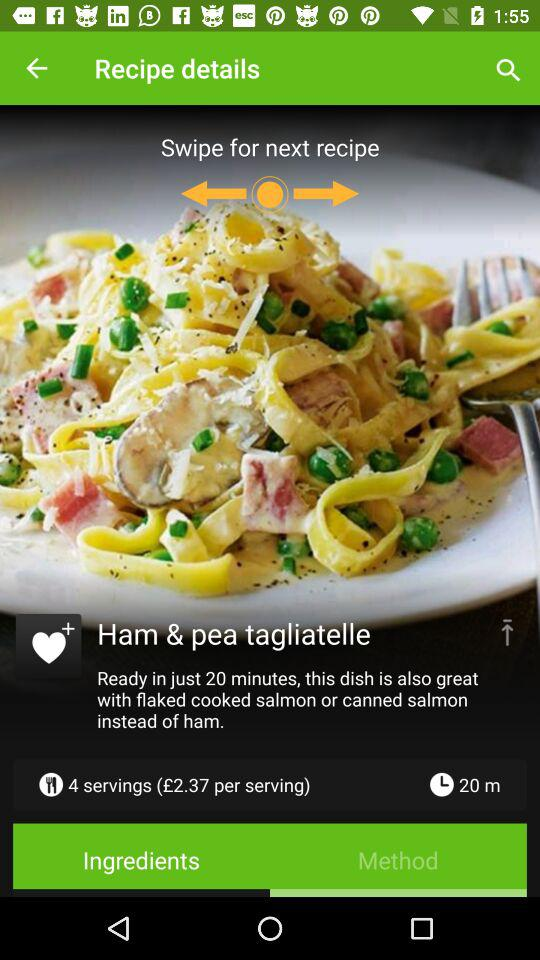How many servings are there for this recipe?
Answer the question using a single word or phrase. 4 